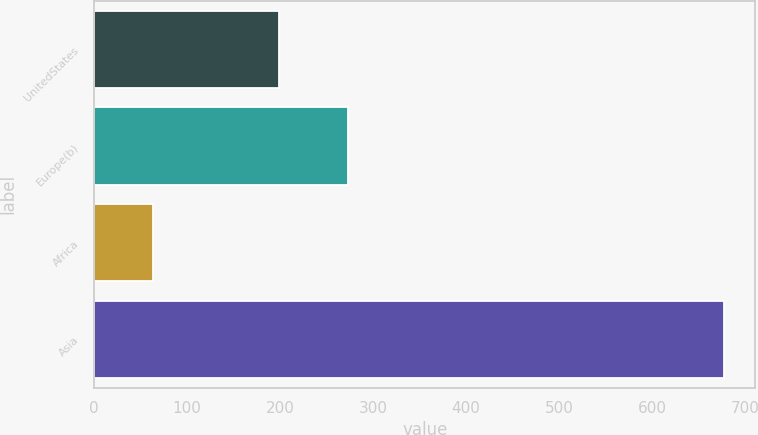<chart> <loc_0><loc_0><loc_500><loc_500><bar_chart><fcel>UnitedStates<fcel>Europe(b)<fcel>Africa<fcel>Asia<nl><fcel>199<fcel>273<fcel>63<fcel>677<nl></chart> 